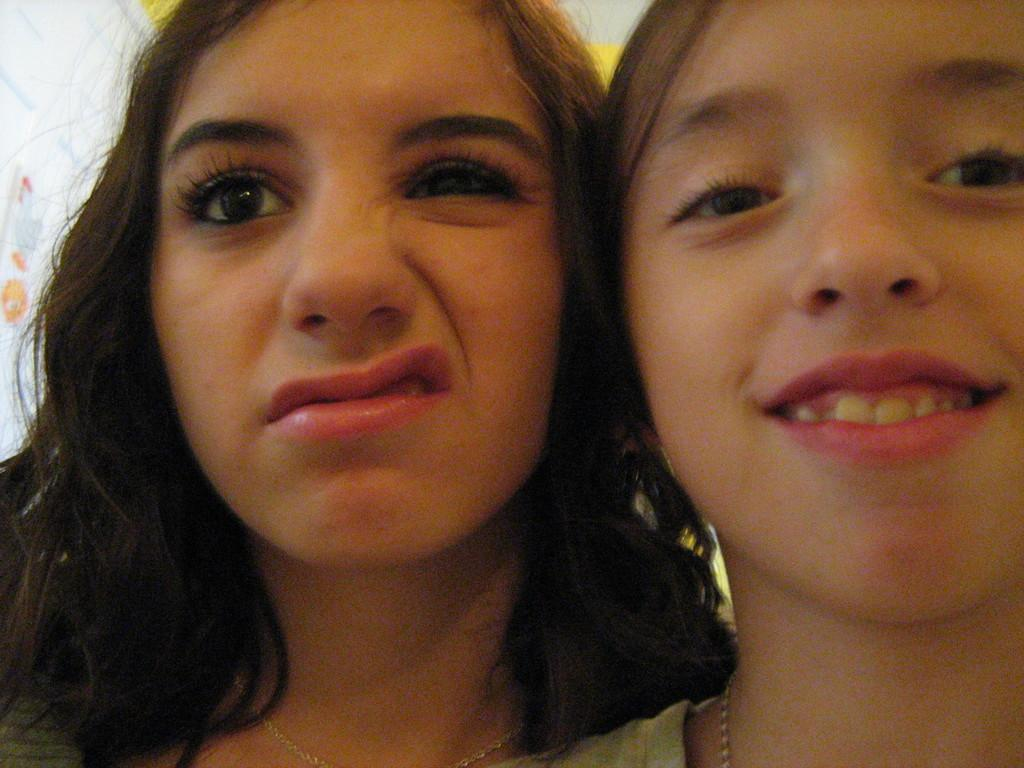How many people are present in the image? There are two people in the image. What can be seen in the background of the image? There is a wall in the background of the image. How many beams are visible on the wall in the image? There is no mention of beams in the image, so we cannot determine their presence or quantity. 